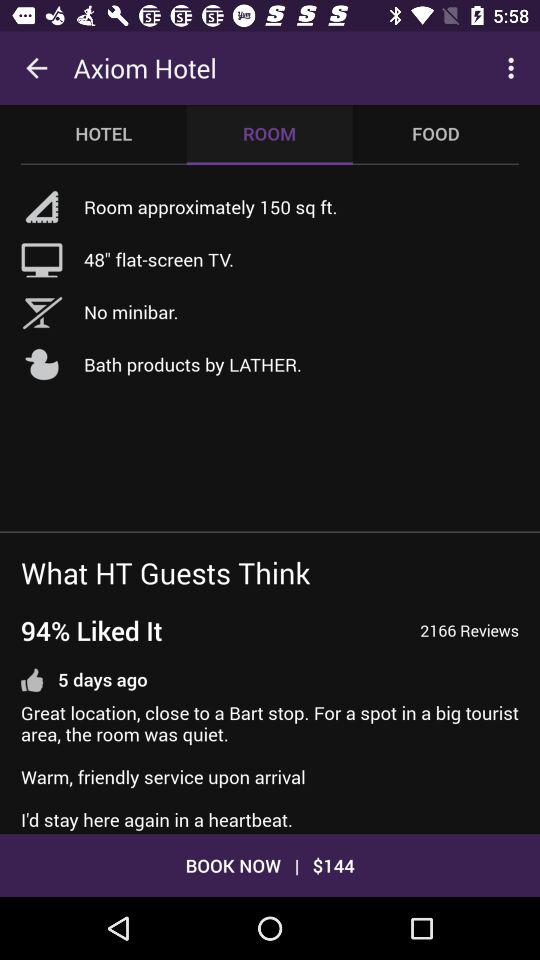What is the size of the television set? The size of the television is 48 inches. 